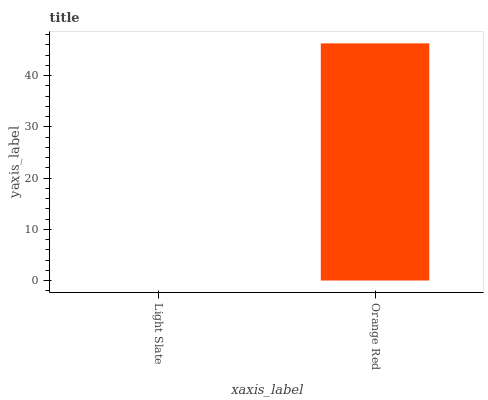Is Orange Red the maximum?
Answer yes or no. Yes. Is Orange Red the minimum?
Answer yes or no. No. Is Orange Red greater than Light Slate?
Answer yes or no. Yes. Is Light Slate less than Orange Red?
Answer yes or no. Yes. Is Light Slate greater than Orange Red?
Answer yes or no. No. Is Orange Red less than Light Slate?
Answer yes or no. No. Is Orange Red the high median?
Answer yes or no. Yes. Is Light Slate the low median?
Answer yes or no. Yes. Is Light Slate the high median?
Answer yes or no. No. Is Orange Red the low median?
Answer yes or no. No. 